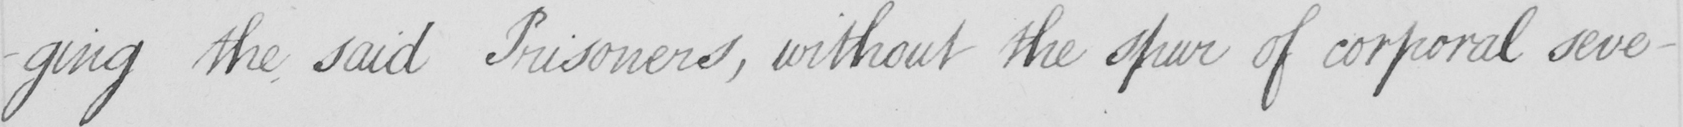Can you tell me what this handwritten text says? -ging the said Prisoners , without the spur of corporal seve- 